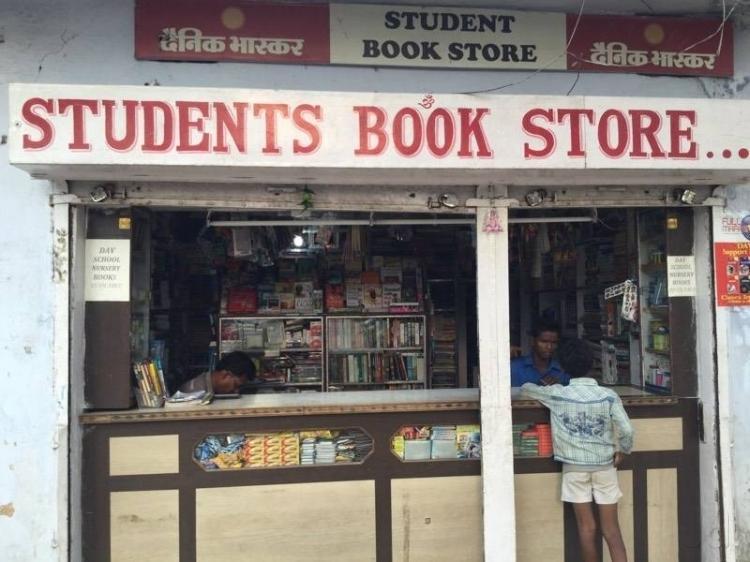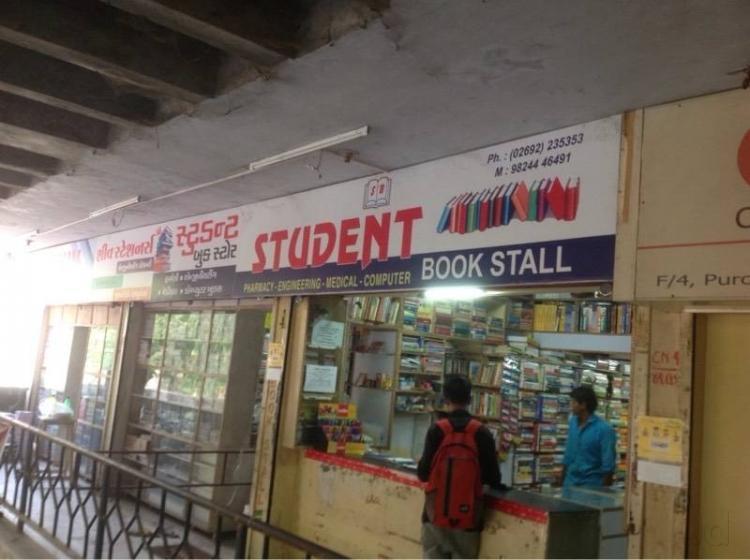The first image is the image on the left, the second image is the image on the right. Given the left and right images, does the statement "At least one image shows a person standing in front of a counter and at least one person in a blue shirt behind a counter, with shelves full of books behind that person." hold true? Answer yes or no. Yes. The first image is the image on the left, the second image is the image on the right. For the images shown, is this caption "A single person is standing out side the book shop in the image on the left." true? Answer yes or no. Yes. 